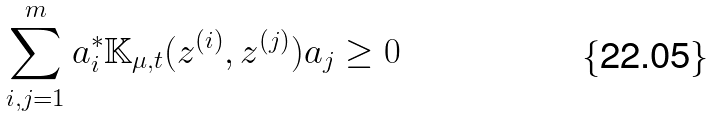Convert formula to latex. <formula><loc_0><loc_0><loc_500><loc_500>\sum _ { i , j = 1 } ^ { m } a _ { i } ^ { * } \mathbb { K } _ { \mu , t } ( z ^ { ( i ) } , z ^ { ( j ) } ) a _ { j } \geq 0</formula> 